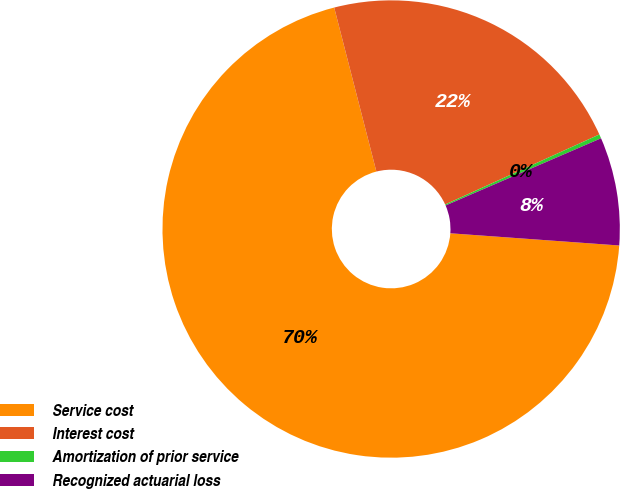<chart> <loc_0><loc_0><loc_500><loc_500><pie_chart><fcel>Service cost<fcel>Interest cost<fcel>Amortization of prior service<fcel>Recognized actuarial loss<nl><fcel>69.84%<fcel>22.22%<fcel>0.29%<fcel>7.64%<nl></chart> 